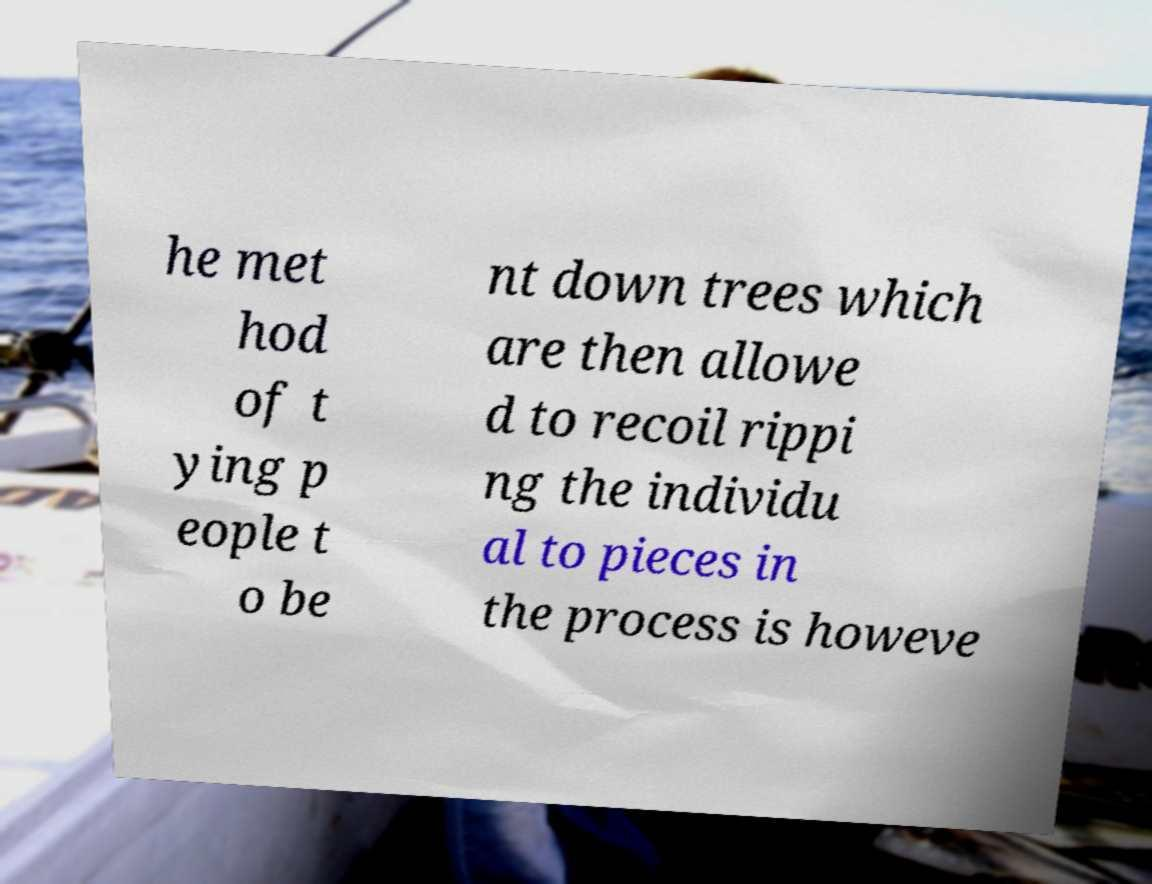For documentation purposes, I need the text within this image transcribed. Could you provide that? he met hod of t ying p eople t o be nt down trees which are then allowe d to recoil rippi ng the individu al to pieces in the process is howeve 